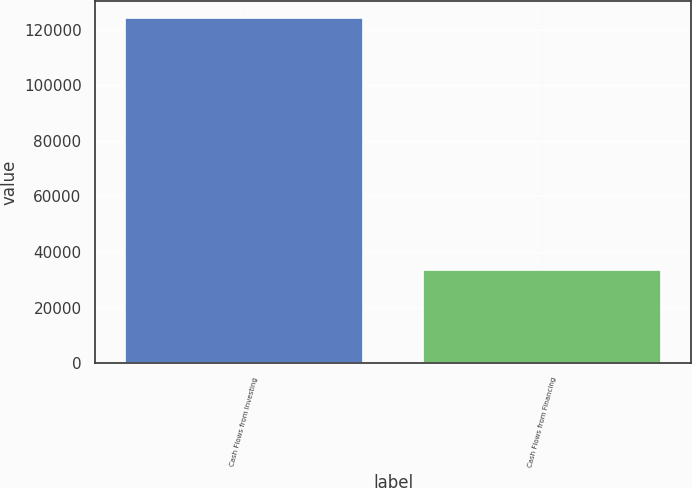Convert chart. <chart><loc_0><loc_0><loc_500><loc_500><bar_chart><fcel>Cash Flows from Investing<fcel>Cash Flows from Financing<nl><fcel>124042<fcel>33662<nl></chart> 